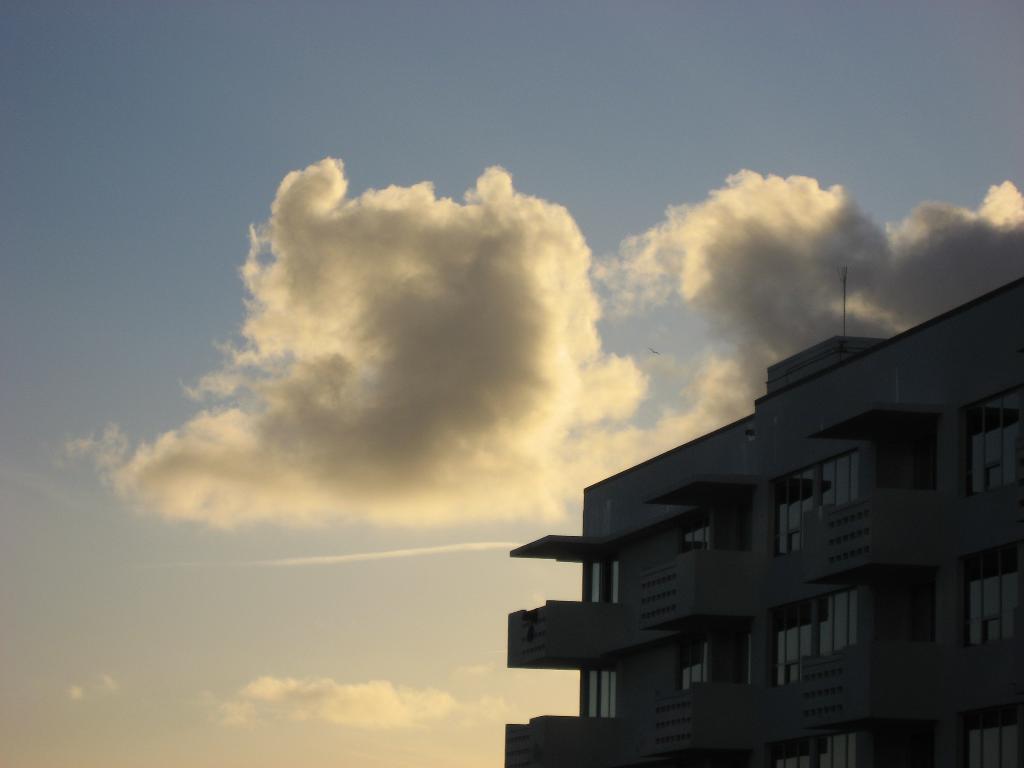Please provide a concise description of this image. In the image there is a building on the right side and above its sky with clouds. 